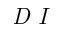<formula> <loc_0><loc_0><loc_500><loc_500>D I</formula> 